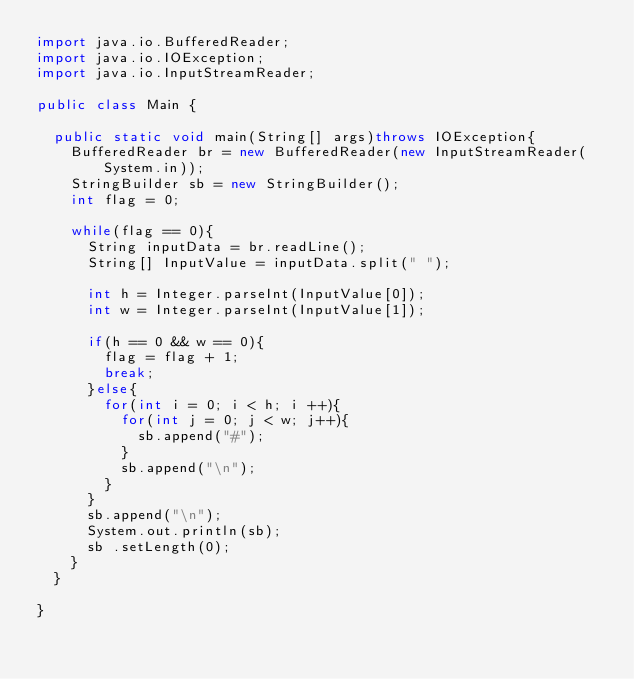<code> <loc_0><loc_0><loc_500><loc_500><_Java_>import java.io.BufferedReader;
import java.io.IOException;
import java.io.InputStreamReader;

public class Main {

	public static void main(String[] args)throws IOException{
		BufferedReader br = new BufferedReader(new InputStreamReader(System.in));
		StringBuilder sb = new StringBuilder();
		int flag = 0;

		while(flag == 0){
			String inputData = br.readLine();
			String[] InputValue = inputData.split(" ");

			int h = Integer.parseInt(InputValue[0]);
			int w = Integer.parseInt(InputValue[1]);

			if(h == 0 && w == 0){
				flag = flag + 1;
				break;
			}else{
				for(int i = 0; i < h; i ++){
					for(int j = 0; j < w; j++){
						sb.append("#");
					}
					sb.append("\n");
				}
			}
			sb.append("\n");
			System.out.println(sb);
			sb .setLength(0);
		}
	}

}</code> 